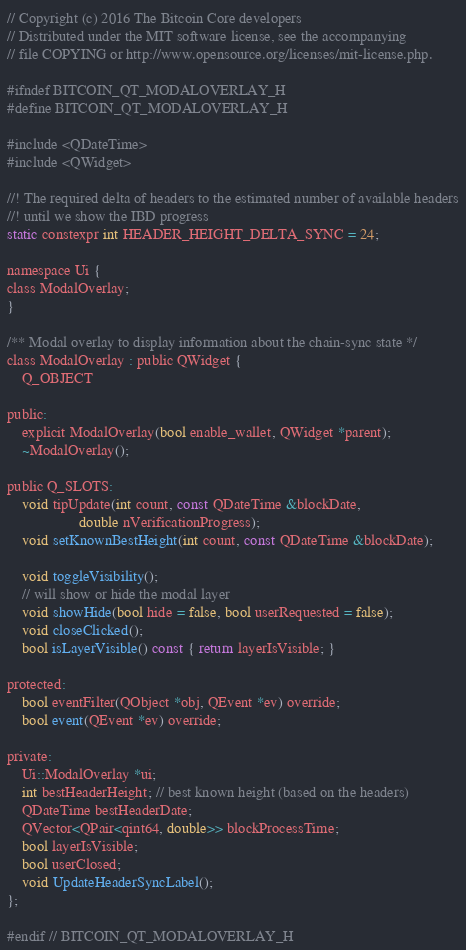<code> <loc_0><loc_0><loc_500><loc_500><_C_>// Copyright (c) 2016 The Bitcoin Core developers
// Distributed under the MIT software license, see the accompanying
// file COPYING or http://www.opensource.org/licenses/mit-license.php.

#ifndef BITCOIN_QT_MODALOVERLAY_H
#define BITCOIN_QT_MODALOVERLAY_H

#include <QDateTime>
#include <QWidget>

//! The required delta of headers to the estimated number of available headers
//! until we show the IBD progress
static constexpr int HEADER_HEIGHT_DELTA_SYNC = 24;

namespace Ui {
class ModalOverlay;
}

/** Modal overlay to display information about the chain-sync state */
class ModalOverlay : public QWidget {
    Q_OBJECT

public:
    explicit ModalOverlay(bool enable_wallet, QWidget *parent);
    ~ModalOverlay();

public Q_SLOTS:
    void tipUpdate(int count, const QDateTime &blockDate,
                   double nVerificationProgress);
    void setKnownBestHeight(int count, const QDateTime &blockDate);

    void toggleVisibility();
    // will show or hide the modal layer
    void showHide(bool hide = false, bool userRequested = false);
    void closeClicked();
    bool isLayerVisible() const { return layerIsVisible; }

protected:
    bool eventFilter(QObject *obj, QEvent *ev) override;
    bool event(QEvent *ev) override;

private:
    Ui::ModalOverlay *ui;
    int bestHeaderHeight; // best known height (based on the headers)
    QDateTime bestHeaderDate;
    QVector<QPair<qint64, double>> blockProcessTime;
    bool layerIsVisible;
    bool userClosed;
    void UpdateHeaderSyncLabel();
};

#endif // BITCOIN_QT_MODALOVERLAY_H
</code> 